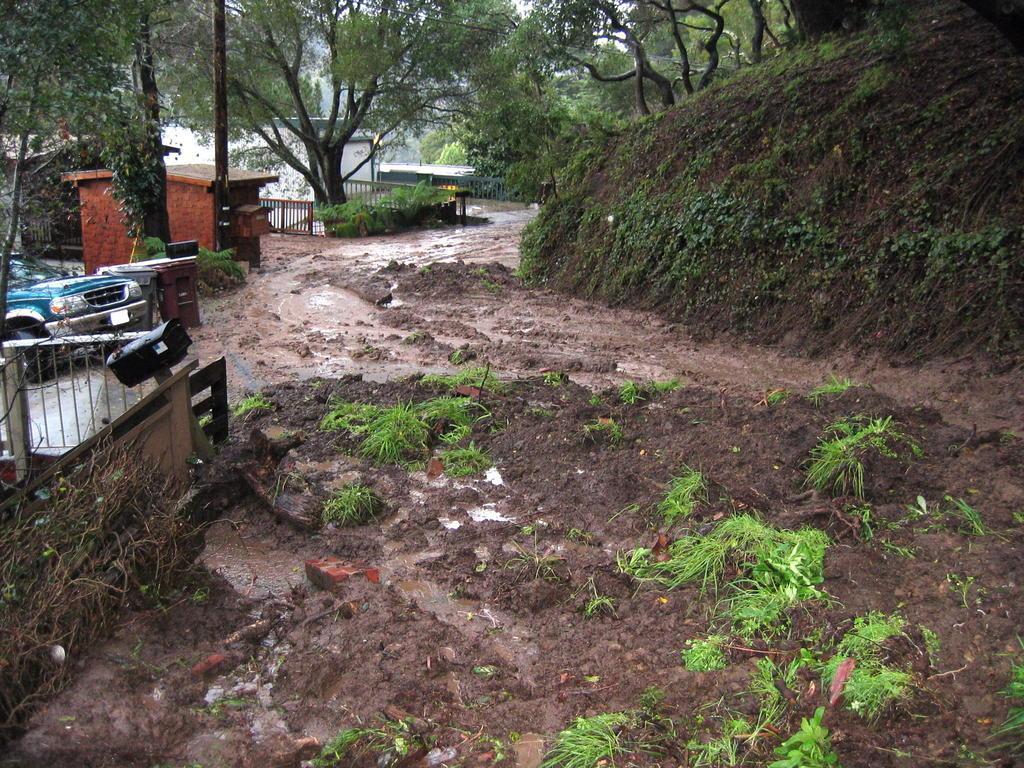How would you summarize this image in a sentence or two? In this image we can see some grass on the ground. On the left side we can see a car parked aside, some houses with roof, a fence and some poles. We can also see a wooden fence, some plants, a building and a group of trees. 